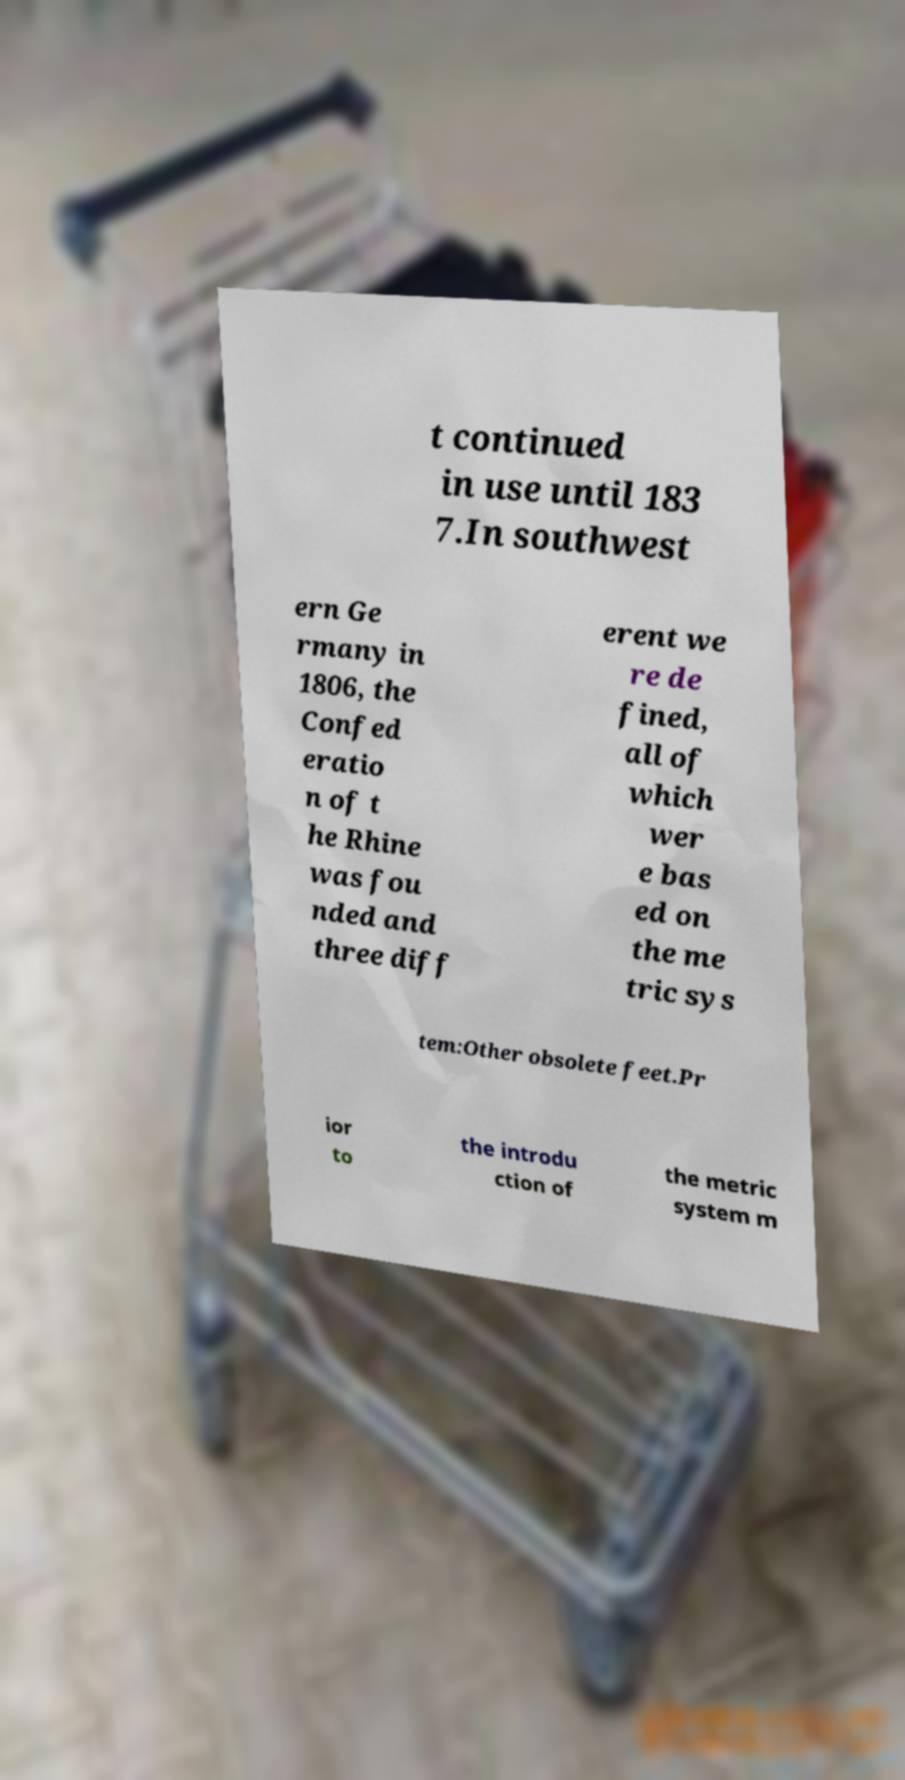Can you accurately transcribe the text from the provided image for me? t continued in use until 183 7.In southwest ern Ge rmany in 1806, the Confed eratio n of t he Rhine was fou nded and three diff erent we re de fined, all of which wer e bas ed on the me tric sys tem:Other obsolete feet.Pr ior to the introdu ction of the metric system m 